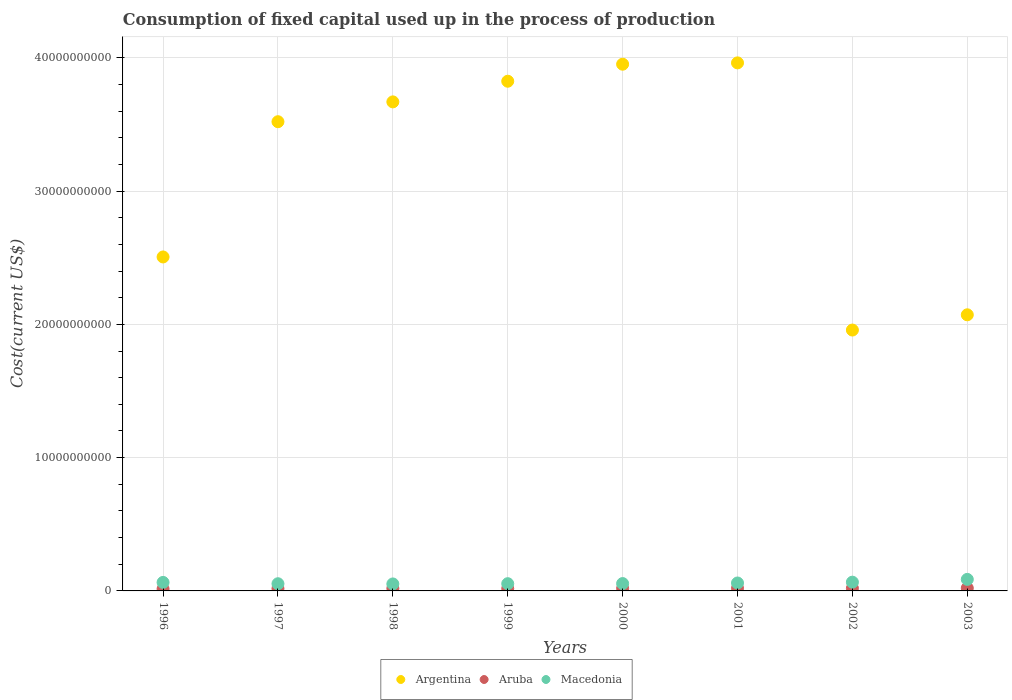How many different coloured dotlines are there?
Your answer should be compact. 3. What is the amount consumed in the process of production in Argentina in 2003?
Your response must be concise. 2.07e+1. Across all years, what is the maximum amount consumed in the process of production in Macedonia?
Offer a very short reply. 8.65e+08. Across all years, what is the minimum amount consumed in the process of production in Argentina?
Your answer should be very brief. 1.96e+1. In which year was the amount consumed in the process of production in Argentina minimum?
Provide a succinct answer. 2002. What is the total amount consumed in the process of production in Argentina in the graph?
Offer a very short reply. 2.55e+11. What is the difference between the amount consumed in the process of production in Macedonia in 1997 and that in 2000?
Your response must be concise. -1.24e+07. What is the difference between the amount consumed in the process of production in Aruba in 2003 and the amount consumed in the process of production in Argentina in 2001?
Your answer should be compact. -3.94e+1. What is the average amount consumed in the process of production in Macedonia per year?
Offer a terse response. 6.14e+08. In the year 2000, what is the difference between the amount consumed in the process of production in Argentina and amount consumed in the process of production in Aruba?
Keep it short and to the point. 3.93e+1. What is the ratio of the amount consumed in the process of production in Aruba in 1996 to that in 2000?
Your answer should be compact. 0.79. Is the difference between the amount consumed in the process of production in Argentina in 1998 and 2002 greater than the difference between the amount consumed in the process of production in Aruba in 1998 and 2002?
Keep it short and to the point. Yes. What is the difference between the highest and the second highest amount consumed in the process of production in Aruba?
Your response must be concise. 8.33e+06. What is the difference between the highest and the lowest amount consumed in the process of production in Macedonia?
Offer a very short reply. 3.42e+08. Does the amount consumed in the process of production in Aruba monotonically increase over the years?
Keep it short and to the point. No. Is the amount consumed in the process of production in Argentina strictly less than the amount consumed in the process of production in Aruba over the years?
Your answer should be very brief. No. How many years are there in the graph?
Offer a terse response. 8. Are the values on the major ticks of Y-axis written in scientific E-notation?
Provide a succinct answer. No. Does the graph contain any zero values?
Your response must be concise. No. Does the graph contain grids?
Ensure brevity in your answer.  Yes. Where does the legend appear in the graph?
Provide a short and direct response. Bottom center. How many legend labels are there?
Make the answer very short. 3. What is the title of the graph?
Provide a succinct answer. Consumption of fixed capital used up in the process of production. Does "Tanzania" appear as one of the legend labels in the graph?
Provide a short and direct response. No. What is the label or title of the X-axis?
Offer a terse response. Years. What is the label or title of the Y-axis?
Make the answer very short. Cost(current US$). What is the Cost(current US$) in Argentina in 1996?
Your response must be concise. 2.51e+1. What is the Cost(current US$) of Aruba in 1996?
Your answer should be very brief. 1.51e+08. What is the Cost(current US$) in Macedonia in 1996?
Ensure brevity in your answer.  6.38e+08. What is the Cost(current US$) of Argentina in 1997?
Your answer should be very brief. 3.52e+1. What is the Cost(current US$) of Aruba in 1997?
Your answer should be very brief. 1.73e+08. What is the Cost(current US$) in Macedonia in 1997?
Give a very brief answer. 5.39e+08. What is the Cost(current US$) in Argentina in 1998?
Offer a very short reply. 3.67e+1. What is the Cost(current US$) of Aruba in 1998?
Provide a short and direct response. 1.85e+08. What is the Cost(current US$) of Macedonia in 1998?
Give a very brief answer. 5.23e+08. What is the Cost(current US$) in Argentina in 1999?
Your answer should be very brief. 3.82e+1. What is the Cost(current US$) in Aruba in 1999?
Your response must be concise. 1.75e+08. What is the Cost(current US$) of Macedonia in 1999?
Your response must be concise. 5.43e+08. What is the Cost(current US$) in Argentina in 2000?
Keep it short and to the point. 3.95e+1. What is the Cost(current US$) of Aruba in 2000?
Offer a very short reply. 1.91e+08. What is the Cost(current US$) in Macedonia in 2000?
Provide a short and direct response. 5.52e+08. What is the Cost(current US$) in Argentina in 2001?
Your response must be concise. 3.96e+1. What is the Cost(current US$) of Aruba in 2001?
Give a very brief answer. 1.98e+08. What is the Cost(current US$) in Macedonia in 2001?
Offer a very short reply. 5.95e+08. What is the Cost(current US$) of Argentina in 2002?
Ensure brevity in your answer.  1.96e+1. What is the Cost(current US$) of Aruba in 2002?
Make the answer very short. 2.00e+08. What is the Cost(current US$) in Macedonia in 2002?
Offer a very short reply. 6.56e+08. What is the Cost(current US$) in Argentina in 2003?
Your answer should be very brief. 2.07e+1. What is the Cost(current US$) of Aruba in 2003?
Provide a succinct answer. 2.09e+08. What is the Cost(current US$) in Macedonia in 2003?
Your answer should be compact. 8.65e+08. Across all years, what is the maximum Cost(current US$) of Argentina?
Your answer should be very brief. 3.96e+1. Across all years, what is the maximum Cost(current US$) in Aruba?
Provide a short and direct response. 2.09e+08. Across all years, what is the maximum Cost(current US$) of Macedonia?
Make the answer very short. 8.65e+08. Across all years, what is the minimum Cost(current US$) of Argentina?
Your response must be concise. 1.96e+1. Across all years, what is the minimum Cost(current US$) in Aruba?
Provide a short and direct response. 1.51e+08. Across all years, what is the minimum Cost(current US$) in Macedonia?
Make the answer very short. 5.23e+08. What is the total Cost(current US$) of Argentina in the graph?
Your answer should be very brief. 2.55e+11. What is the total Cost(current US$) in Aruba in the graph?
Give a very brief answer. 1.48e+09. What is the total Cost(current US$) of Macedonia in the graph?
Your answer should be very brief. 4.91e+09. What is the difference between the Cost(current US$) of Argentina in 1996 and that in 1997?
Keep it short and to the point. -1.01e+1. What is the difference between the Cost(current US$) of Aruba in 1996 and that in 1997?
Make the answer very short. -2.18e+07. What is the difference between the Cost(current US$) of Macedonia in 1996 and that in 1997?
Your answer should be compact. 9.88e+07. What is the difference between the Cost(current US$) of Argentina in 1996 and that in 1998?
Provide a succinct answer. -1.16e+1. What is the difference between the Cost(current US$) in Aruba in 1996 and that in 1998?
Make the answer very short. -3.41e+07. What is the difference between the Cost(current US$) in Macedonia in 1996 and that in 1998?
Give a very brief answer. 1.15e+08. What is the difference between the Cost(current US$) in Argentina in 1996 and that in 1999?
Provide a short and direct response. -1.32e+1. What is the difference between the Cost(current US$) in Aruba in 1996 and that in 1999?
Your response must be concise. -2.41e+07. What is the difference between the Cost(current US$) of Macedonia in 1996 and that in 1999?
Offer a very short reply. 9.54e+07. What is the difference between the Cost(current US$) in Argentina in 1996 and that in 2000?
Your answer should be very brief. -1.45e+1. What is the difference between the Cost(current US$) of Aruba in 1996 and that in 2000?
Keep it short and to the point. -4.07e+07. What is the difference between the Cost(current US$) of Macedonia in 1996 and that in 2000?
Keep it short and to the point. 8.64e+07. What is the difference between the Cost(current US$) of Argentina in 1996 and that in 2001?
Offer a terse response. -1.46e+1. What is the difference between the Cost(current US$) in Aruba in 1996 and that in 2001?
Offer a terse response. -4.70e+07. What is the difference between the Cost(current US$) in Macedonia in 1996 and that in 2001?
Keep it short and to the point. 4.34e+07. What is the difference between the Cost(current US$) in Argentina in 1996 and that in 2002?
Your response must be concise. 5.48e+09. What is the difference between the Cost(current US$) in Aruba in 1996 and that in 2002?
Offer a very short reply. -4.95e+07. What is the difference between the Cost(current US$) in Macedonia in 1996 and that in 2002?
Your response must be concise. -1.80e+07. What is the difference between the Cost(current US$) of Argentina in 1996 and that in 2003?
Your response must be concise. 4.34e+09. What is the difference between the Cost(current US$) of Aruba in 1996 and that in 2003?
Ensure brevity in your answer.  -5.78e+07. What is the difference between the Cost(current US$) in Macedonia in 1996 and that in 2003?
Provide a succinct answer. -2.27e+08. What is the difference between the Cost(current US$) of Argentina in 1997 and that in 1998?
Your answer should be very brief. -1.49e+09. What is the difference between the Cost(current US$) of Aruba in 1997 and that in 1998?
Your answer should be very brief. -1.23e+07. What is the difference between the Cost(current US$) in Macedonia in 1997 and that in 1998?
Give a very brief answer. 1.57e+07. What is the difference between the Cost(current US$) of Argentina in 1997 and that in 1999?
Make the answer very short. -3.04e+09. What is the difference between the Cost(current US$) of Aruba in 1997 and that in 1999?
Your answer should be compact. -2.22e+06. What is the difference between the Cost(current US$) of Macedonia in 1997 and that in 1999?
Your answer should be very brief. -3.48e+06. What is the difference between the Cost(current US$) in Argentina in 1997 and that in 2000?
Your answer should be compact. -4.31e+09. What is the difference between the Cost(current US$) of Aruba in 1997 and that in 2000?
Provide a short and direct response. -1.88e+07. What is the difference between the Cost(current US$) of Macedonia in 1997 and that in 2000?
Offer a very short reply. -1.24e+07. What is the difference between the Cost(current US$) in Argentina in 1997 and that in 2001?
Your answer should be compact. -4.41e+09. What is the difference between the Cost(current US$) in Aruba in 1997 and that in 2001?
Make the answer very short. -2.51e+07. What is the difference between the Cost(current US$) of Macedonia in 1997 and that in 2001?
Provide a short and direct response. -5.55e+07. What is the difference between the Cost(current US$) in Argentina in 1997 and that in 2002?
Make the answer very short. 1.56e+1. What is the difference between the Cost(current US$) in Aruba in 1997 and that in 2002?
Offer a very short reply. -2.77e+07. What is the difference between the Cost(current US$) in Macedonia in 1997 and that in 2002?
Your response must be concise. -1.17e+08. What is the difference between the Cost(current US$) in Argentina in 1997 and that in 2003?
Make the answer very short. 1.45e+1. What is the difference between the Cost(current US$) in Aruba in 1997 and that in 2003?
Keep it short and to the point. -3.60e+07. What is the difference between the Cost(current US$) in Macedonia in 1997 and that in 2003?
Offer a terse response. -3.26e+08. What is the difference between the Cost(current US$) of Argentina in 1998 and that in 1999?
Provide a succinct answer. -1.55e+09. What is the difference between the Cost(current US$) in Aruba in 1998 and that in 1999?
Keep it short and to the point. 1.01e+07. What is the difference between the Cost(current US$) of Macedonia in 1998 and that in 1999?
Your response must be concise. -1.92e+07. What is the difference between the Cost(current US$) in Argentina in 1998 and that in 2000?
Give a very brief answer. -2.83e+09. What is the difference between the Cost(current US$) in Aruba in 1998 and that in 2000?
Provide a short and direct response. -6.54e+06. What is the difference between the Cost(current US$) in Macedonia in 1998 and that in 2000?
Offer a very short reply. -2.82e+07. What is the difference between the Cost(current US$) in Argentina in 1998 and that in 2001?
Offer a terse response. -2.93e+09. What is the difference between the Cost(current US$) of Aruba in 1998 and that in 2001?
Make the answer very short. -1.28e+07. What is the difference between the Cost(current US$) in Macedonia in 1998 and that in 2001?
Offer a very short reply. -7.12e+07. What is the difference between the Cost(current US$) in Argentina in 1998 and that in 2002?
Provide a short and direct response. 1.71e+1. What is the difference between the Cost(current US$) of Aruba in 1998 and that in 2002?
Keep it short and to the point. -1.54e+07. What is the difference between the Cost(current US$) of Macedonia in 1998 and that in 2002?
Offer a very short reply. -1.33e+08. What is the difference between the Cost(current US$) in Argentina in 1998 and that in 2003?
Your answer should be very brief. 1.60e+1. What is the difference between the Cost(current US$) of Aruba in 1998 and that in 2003?
Give a very brief answer. -2.37e+07. What is the difference between the Cost(current US$) of Macedonia in 1998 and that in 2003?
Provide a short and direct response. -3.42e+08. What is the difference between the Cost(current US$) in Argentina in 1999 and that in 2000?
Provide a short and direct response. -1.28e+09. What is the difference between the Cost(current US$) of Aruba in 1999 and that in 2000?
Make the answer very short. -1.66e+07. What is the difference between the Cost(current US$) in Macedonia in 1999 and that in 2000?
Ensure brevity in your answer.  -8.94e+06. What is the difference between the Cost(current US$) of Argentina in 1999 and that in 2001?
Keep it short and to the point. -1.38e+09. What is the difference between the Cost(current US$) of Aruba in 1999 and that in 2001?
Your response must be concise. -2.29e+07. What is the difference between the Cost(current US$) in Macedonia in 1999 and that in 2001?
Your answer should be compact. -5.20e+07. What is the difference between the Cost(current US$) of Argentina in 1999 and that in 2002?
Ensure brevity in your answer.  1.87e+1. What is the difference between the Cost(current US$) of Aruba in 1999 and that in 2002?
Give a very brief answer. -2.54e+07. What is the difference between the Cost(current US$) of Macedonia in 1999 and that in 2002?
Give a very brief answer. -1.13e+08. What is the difference between the Cost(current US$) in Argentina in 1999 and that in 2003?
Your answer should be compact. 1.75e+1. What is the difference between the Cost(current US$) of Aruba in 1999 and that in 2003?
Offer a terse response. -3.38e+07. What is the difference between the Cost(current US$) of Macedonia in 1999 and that in 2003?
Provide a succinct answer. -3.23e+08. What is the difference between the Cost(current US$) of Argentina in 2000 and that in 2001?
Ensure brevity in your answer.  -9.96e+07. What is the difference between the Cost(current US$) in Aruba in 2000 and that in 2001?
Offer a terse response. -6.28e+06. What is the difference between the Cost(current US$) of Macedonia in 2000 and that in 2001?
Keep it short and to the point. -4.30e+07. What is the difference between the Cost(current US$) in Argentina in 2000 and that in 2002?
Make the answer very short. 1.99e+1. What is the difference between the Cost(current US$) of Aruba in 2000 and that in 2002?
Your answer should be very brief. -8.83e+06. What is the difference between the Cost(current US$) in Macedonia in 2000 and that in 2002?
Keep it short and to the point. -1.04e+08. What is the difference between the Cost(current US$) in Argentina in 2000 and that in 2003?
Offer a very short reply. 1.88e+1. What is the difference between the Cost(current US$) of Aruba in 2000 and that in 2003?
Make the answer very short. -1.72e+07. What is the difference between the Cost(current US$) of Macedonia in 2000 and that in 2003?
Keep it short and to the point. -3.14e+08. What is the difference between the Cost(current US$) of Argentina in 2001 and that in 2002?
Your answer should be compact. 2.00e+1. What is the difference between the Cost(current US$) in Aruba in 2001 and that in 2002?
Ensure brevity in your answer.  -2.55e+06. What is the difference between the Cost(current US$) in Macedonia in 2001 and that in 2002?
Your response must be concise. -6.14e+07. What is the difference between the Cost(current US$) in Argentina in 2001 and that in 2003?
Offer a very short reply. 1.89e+1. What is the difference between the Cost(current US$) in Aruba in 2001 and that in 2003?
Your answer should be very brief. -1.09e+07. What is the difference between the Cost(current US$) in Macedonia in 2001 and that in 2003?
Offer a very short reply. -2.71e+08. What is the difference between the Cost(current US$) of Argentina in 2002 and that in 2003?
Provide a short and direct response. -1.14e+09. What is the difference between the Cost(current US$) in Aruba in 2002 and that in 2003?
Keep it short and to the point. -8.33e+06. What is the difference between the Cost(current US$) in Macedonia in 2002 and that in 2003?
Offer a terse response. -2.09e+08. What is the difference between the Cost(current US$) of Argentina in 1996 and the Cost(current US$) of Aruba in 1997?
Provide a short and direct response. 2.49e+1. What is the difference between the Cost(current US$) in Argentina in 1996 and the Cost(current US$) in Macedonia in 1997?
Keep it short and to the point. 2.45e+1. What is the difference between the Cost(current US$) of Aruba in 1996 and the Cost(current US$) of Macedonia in 1997?
Provide a succinct answer. -3.88e+08. What is the difference between the Cost(current US$) of Argentina in 1996 and the Cost(current US$) of Aruba in 1998?
Provide a succinct answer. 2.49e+1. What is the difference between the Cost(current US$) in Argentina in 1996 and the Cost(current US$) in Macedonia in 1998?
Provide a succinct answer. 2.45e+1. What is the difference between the Cost(current US$) in Aruba in 1996 and the Cost(current US$) in Macedonia in 1998?
Offer a very short reply. -3.73e+08. What is the difference between the Cost(current US$) in Argentina in 1996 and the Cost(current US$) in Aruba in 1999?
Provide a short and direct response. 2.49e+1. What is the difference between the Cost(current US$) of Argentina in 1996 and the Cost(current US$) of Macedonia in 1999?
Make the answer very short. 2.45e+1. What is the difference between the Cost(current US$) of Aruba in 1996 and the Cost(current US$) of Macedonia in 1999?
Give a very brief answer. -3.92e+08. What is the difference between the Cost(current US$) in Argentina in 1996 and the Cost(current US$) in Aruba in 2000?
Keep it short and to the point. 2.49e+1. What is the difference between the Cost(current US$) in Argentina in 1996 and the Cost(current US$) in Macedonia in 2000?
Provide a succinct answer. 2.45e+1. What is the difference between the Cost(current US$) in Aruba in 1996 and the Cost(current US$) in Macedonia in 2000?
Your answer should be compact. -4.01e+08. What is the difference between the Cost(current US$) in Argentina in 1996 and the Cost(current US$) in Aruba in 2001?
Your answer should be very brief. 2.49e+1. What is the difference between the Cost(current US$) of Argentina in 1996 and the Cost(current US$) of Macedonia in 2001?
Keep it short and to the point. 2.45e+1. What is the difference between the Cost(current US$) in Aruba in 1996 and the Cost(current US$) in Macedonia in 2001?
Your answer should be very brief. -4.44e+08. What is the difference between the Cost(current US$) in Argentina in 1996 and the Cost(current US$) in Aruba in 2002?
Keep it short and to the point. 2.49e+1. What is the difference between the Cost(current US$) in Argentina in 1996 and the Cost(current US$) in Macedonia in 2002?
Offer a very short reply. 2.44e+1. What is the difference between the Cost(current US$) of Aruba in 1996 and the Cost(current US$) of Macedonia in 2002?
Ensure brevity in your answer.  -5.05e+08. What is the difference between the Cost(current US$) of Argentina in 1996 and the Cost(current US$) of Aruba in 2003?
Offer a very short reply. 2.49e+1. What is the difference between the Cost(current US$) in Argentina in 1996 and the Cost(current US$) in Macedonia in 2003?
Your response must be concise. 2.42e+1. What is the difference between the Cost(current US$) in Aruba in 1996 and the Cost(current US$) in Macedonia in 2003?
Offer a very short reply. -7.15e+08. What is the difference between the Cost(current US$) in Argentina in 1997 and the Cost(current US$) in Aruba in 1998?
Give a very brief answer. 3.50e+1. What is the difference between the Cost(current US$) in Argentina in 1997 and the Cost(current US$) in Macedonia in 1998?
Ensure brevity in your answer.  3.47e+1. What is the difference between the Cost(current US$) in Aruba in 1997 and the Cost(current US$) in Macedonia in 1998?
Provide a short and direct response. -3.51e+08. What is the difference between the Cost(current US$) in Argentina in 1997 and the Cost(current US$) in Aruba in 1999?
Offer a terse response. 3.50e+1. What is the difference between the Cost(current US$) of Argentina in 1997 and the Cost(current US$) of Macedonia in 1999?
Your answer should be compact. 3.47e+1. What is the difference between the Cost(current US$) in Aruba in 1997 and the Cost(current US$) in Macedonia in 1999?
Keep it short and to the point. -3.70e+08. What is the difference between the Cost(current US$) of Argentina in 1997 and the Cost(current US$) of Aruba in 2000?
Ensure brevity in your answer.  3.50e+1. What is the difference between the Cost(current US$) of Argentina in 1997 and the Cost(current US$) of Macedonia in 2000?
Offer a very short reply. 3.47e+1. What is the difference between the Cost(current US$) in Aruba in 1997 and the Cost(current US$) in Macedonia in 2000?
Offer a very short reply. -3.79e+08. What is the difference between the Cost(current US$) in Argentina in 1997 and the Cost(current US$) in Aruba in 2001?
Keep it short and to the point. 3.50e+1. What is the difference between the Cost(current US$) of Argentina in 1997 and the Cost(current US$) of Macedonia in 2001?
Make the answer very short. 3.46e+1. What is the difference between the Cost(current US$) of Aruba in 1997 and the Cost(current US$) of Macedonia in 2001?
Keep it short and to the point. -4.22e+08. What is the difference between the Cost(current US$) in Argentina in 1997 and the Cost(current US$) in Aruba in 2002?
Give a very brief answer. 3.50e+1. What is the difference between the Cost(current US$) in Argentina in 1997 and the Cost(current US$) in Macedonia in 2002?
Provide a succinct answer. 3.46e+1. What is the difference between the Cost(current US$) of Aruba in 1997 and the Cost(current US$) of Macedonia in 2002?
Make the answer very short. -4.83e+08. What is the difference between the Cost(current US$) of Argentina in 1997 and the Cost(current US$) of Aruba in 2003?
Provide a succinct answer. 3.50e+1. What is the difference between the Cost(current US$) of Argentina in 1997 and the Cost(current US$) of Macedonia in 2003?
Give a very brief answer. 3.43e+1. What is the difference between the Cost(current US$) of Aruba in 1997 and the Cost(current US$) of Macedonia in 2003?
Ensure brevity in your answer.  -6.93e+08. What is the difference between the Cost(current US$) in Argentina in 1998 and the Cost(current US$) in Aruba in 1999?
Offer a very short reply. 3.65e+1. What is the difference between the Cost(current US$) in Argentina in 1998 and the Cost(current US$) in Macedonia in 1999?
Offer a very short reply. 3.62e+1. What is the difference between the Cost(current US$) in Aruba in 1998 and the Cost(current US$) in Macedonia in 1999?
Offer a terse response. -3.58e+08. What is the difference between the Cost(current US$) of Argentina in 1998 and the Cost(current US$) of Aruba in 2000?
Offer a terse response. 3.65e+1. What is the difference between the Cost(current US$) of Argentina in 1998 and the Cost(current US$) of Macedonia in 2000?
Keep it short and to the point. 3.61e+1. What is the difference between the Cost(current US$) of Aruba in 1998 and the Cost(current US$) of Macedonia in 2000?
Your response must be concise. -3.67e+08. What is the difference between the Cost(current US$) in Argentina in 1998 and the Cost(current US$) in Aruba in 2001?
Your answer should be compact. 3.65e+1. What is the difference between the Cost(current US$) in Argentina in 1998 and the Cost(current US$) in Macedonia in 2001?
Your answer should be compact. 3.61e+1. What is the difference between the Cost(current US$) of Aruba in 1998 and the Cost(current US$) of Macedonia in 2001?
Your answer should be very brief. -4.10e+08. What is the difference between the Cost(current US$) in Argentina in 1998 and the Cost(current US$) in Aruba in 2002?
Provide a short and direct response. 3.65e+1. What is the difference between the Cost(current US$) in Argentina in 1998 and the Cost(current US$) in Macedonia in 2002?
Your response must be concise. 3.60e+1. What is the difference between the Cost(current US$) in Aruba in 1998 and the Cost(current US$) in Macedonia in 2002?
Keep it short and to the point. -4.71e+08. What is the difference between the Cost(current US$) of Argentina in 1998 and the Cost(current US$) of Aruba in 2003?
Provide a short and direct response. 3.65e+1. What is the difference between the Cost(current US$) in Argentina in 1998 and the Cost(current US$) in Macedonia in 2003?
Make the answer very short. 3.58e+1. What is the difference between the Cost(current US$) in Aruba in 1998 and the Cost(current US$) in Macedonia in 2003?
Offer a very short reply. -6.80e+08. What is the difference between the Cost(current US$) in Argentina in 1999 and the Cost(current US$) in Aruba in 2000?
Offer a very short reply. 3.81e+1. What is the difference between the Cost(current US$) in Argentina in 1999 and the Cost(current US$) in Macedonia in 2000?
Provide a succinct answer. 3.77e+1. What is the difference between the Cost(current US$) of Aruba in 1999 and the Cost(current US$) of Macedonia in 2000?
Ensure brevity in your answer.  -3.77e+08. What is the difference between the Cost(current US$) of Argentina in 1999 and the Cost(current US$) of Aruba in 2001?
Ensure brevity in your answer.  3.80e+1. What is the difference between the Cost(current US$) in Argentina in 1999 and the Cost(current US$) in Macedonia in 2001?
Give a very brief answer. 3.77e+1. What is the difference between the Cost(current US$) in Aruba in 1999 and the Cost(current US$) in Macedonia in 2001?
Your response must be concise. -4.20e+08. What is the difference between the Cost(current US$) of Argentina in 1999 and the Cost(current US$) of Aruba in 2002?
Offer a terse response. 3.80e+1. What is the difference between the Cost(current US$) in Argentina in 1999 and the Cost(current US$) in Macedonia in 2002?
Keep it short and to the point. 3.76e+1. What is the difference between the Cost(current US$) of Aruba in 1999 and the Cost(current US$) of Macedonia in 2002?
Provide a succinct answer. -4.81e+08. What is the difference between the Cost(current US$) of Argentina in 1999 and the Cost(current US$) of Aruba in 2003?
Offer a very short reply. 3.80e+1. What is the difference between the Cost(current US$) of Argentina in 1999 and the Cost(current US$) of Macedonia in 2003?
Provide a succinct answer. 3.74e+1. What is the difference between the Cost(current US$) in Aruba in 1999 and the Cost(current US$) in Macedonia in 2003?
Provide a succinct answer. -6.91e+08. What is the difference between the Cost(current US$) in Argentina in 2000 and the Cost(current US$) in Aruba in 2001?
Give a very brief answer. 3.93e+1. What is the difference between the Cost(current US$) in Argentina in 2000 and the Cost(current US$) in Macedonia in 2001?
Give a very brief answer. 3.89e+1. What is the difference between the Cost(current US$) of Aruba in 2000 and the Cost(current US$) of Macedonia in 2001?
Your answer should be very brief. -4.03e+08. What is the difference between the Cost(current US$) in Argentina in 2000 and the Cost(current US$) in Aruba in 2002?
Keep it short and to the point. 3.93e+1. What is the difference between the Cost(current US$) in Argentina in 2000 and the Cost(current US$) in Macedonia in 2002?
Ensure brevity in your answer.  3.89e+1. What is the difference between the Cost(current US$) of Aruba in 2000 and the Cost(current US$) of Macedonia in 2002?
Provide a succinct answer. -4.65e+08. What is the difference between the Cost(current US$) of Argentina in 2000 and the Cost(current US$) of Aruba in 2003?
Your answer should be compact. 3.93e+1. What is the difference between the Cost(current US$) of Argentina in 2000 and the Cost(current US$) of Macedonia in 2003?
Your response must be concise. 3.87e+1. What is the difference between the Cost(current US$) in Aruba in 2000 and the Cost(current US$) in Macedonia in 2003?
Offer a very short reply. -6.74e+08. What is the difference between the Cost(current US$) in Argentina in 2001 and the Cost(current US$) in Aruba in 2002?
Offer a very short reply. 3.94e+1. What is the difference between the Cost(current US$) in Argentina in 2001 and the Cost(current US$) in Macedonia in 2002?
Offer a very short reply. 3.90e+1. What is the difference between the Cost(current US$) of Aruba in 2001 and the Cost(current US$) of Macedonia in 2002?
Your response must be concise. -4.58e+08. What is the difference between the Cost(current US$) in Argentina in 2001 and the Cost(current US$) in Aruba in 2003?
Provide a succinct answer. 3.94e+1. What is the difference between the Cost(current US$) of Argentina in 2001 and the Cost(current US$) of Macedonia in 2003?
Offer a very short reply. 3.88e+1. What is the difference between the Cost(current US$) in Aruba in 2001 and the Cost(current US$) in Macedonia in 2003?
Ensure brevity in your answer.  -6.68e+08. What is the difference between the Cost(current US$) of Argentina in 2002 and the Cost(current US$) of Aruba in 2003?
Give a very brief answer. 1.94e+1. What is the difference between the Cost(current US$) in Argentina in 2002 and the Cost(current US$) in Macedonia in 2003?
Your answer should be compact. 1.87e+1. What is the difference between the Cost(current US$) of Aruba in 2002 and the Cost(current US$) of Macedonia in 2003?
Offer a very short reply. -6.65e+08. What is the average Cost(current US$) in Argentina per year?
Keep it short and to the point. 3.18e+1. What is the average Cost(current US$) in Aruba per year?
Give a very brief answer. 1.85e+08. What is the average Cost(current US$) of Macedonia per year?
Your answer should be very brief. 6.14e+08. In the year 1996, what is the difference between the Cost(current US$) of Argentina and Cost(current US$) of Aruba?
Offer a very short reply. 2.49e+1. In the year 1996, what is the difference between the Cost(current US$) of Argentina and Cost(current US$) of Macedonia?
Offer a terse response. 2.44e+1. In the year 1996, what is the difference between the Cost(current US$) in Aruba and Cost(current US$) in Macedonia?
Make the answer very short. -4.87e+08. In the year 1997, what is the difference between the Cost(current US$) of Argentina and Cost(current US$) of Aruba?
Give a very brief answer. 3.50e+1. In the year 1997, what is the difference between the Cost(current US$) of Argentina and Cost(current US$) of Macedonia?
Make the answer very short. 3.47e+1. In the year 1997, what is the difference between the Cost(current US$) of Aruba and Cost(current US$) of Macedonia?
Ensure brevity in your answer.  -3.67e+08. In the year 1998, what is the difference between the Cost(current US$) of Argentina and Cost(current US$) of Aruba?
Your answer should be compact. 3.65e+1. In the year 1998, what is the difference between the Cost(current US$) of Argentina and Cost(current US$) of Macedonia?
Provide a succinct answer. 3.62e+1. In the year 1998, what is the difference between the Cost(current US$) of Aruba and Cost(current US$) of Macedonia?
Keep it short and to the point. -3.39e+08. In the year 1999, what is the difference between the Cost(current US$) of Argentina and Cost(current US$) of Aruba?
Your response must be concise. 3.81e+1. In the year 1999, what is the difference between the Cost(current US$) of Argentina and Cost(current US$) of Macedonia?
Ensure brevity in your answer.  3.77e+1. In the year 1999, what is the difference between the Cost(current US$) in Aruba and Cost(current US$) in Macedonia?
Make the answer very short. -3.68e+08. In the year 2000, what is the difference between the Cost(current US$) in Argentina and Cost(current US$) in Aruba?
Your answer should be compact. 3.93e+1. In the year 2000, what is the difference between the Cost(current US$) of Argentina and Cost(current US$) of Macedonia?
Offer a terse response. 3.90e+1. In the year 2000, what is the difference between the Cost(current US$) in Aruba and Cost(current US$) in Macedonia?
Keep it short and to the point. -3.60e+08. In the year 2001, what is the difference between the Cost(current US$) of Argentina and Cost(current US$) of Aruba?
Make the answer very short. 3.94e+1. In the year 2001, what is the difference between the Cost(current US$) of Argentina and Cost(current US$) of Macedonia?
Keep it short and to the point. 3.90e+1. In the year 2001, what is the difference between the Cost(current US$) of Aruba and Cost(current US$) of Macedonia?
Offer a terse response. -3.97e+08. In the year 2002, what is the difference between the Cost(current US$) in Argentina and Cost(current US$) in Aruba?
Ensure brevity in your answer.  1.94e+1. In the year 2002, what is the difference between the Cost(current US$) in Argentina and Cost(current US$) in Macedonia?
Your answer should be very brief. 1.89e+1. In the year 2002, what is the difference between the Cost(current US$) of Aruba and Cost(current US$) of Macedonia?
Provide a succinct answer. -4.56e+08. In the year 2003, what is the difference between the Cost(current US$) in Argentina and Cost(current US$) in Aruba?
Offer a very short reply. 2.05e+1. In the year 2003, what is the difference between the Cost(current US$) of Argentina and Cost(current US$) of Macedonia?
Keep it short and to the point. 1.99e+1. In the year 2003, what is the difference between the Cost(current US$) of Aruba and Cost(current US$) of Macedonia?
Make the answer very short. -6.57e+08. What is the ratio of the Cost(current US$) in Argentina in 1996 to that in 1997?
Provide a succinct answer. 0.71. What is the ratio of the Cost(current US$) of Aruba in 1996 to that in 1997?
Make the answer very short. 0.87. What is the ratio of the Cost(current US$) in Macedonia in 1996 to that in 1997?
Ensure brevity in your answer.  1.18. What is the ratio of the Cost(current US$) of Argentina in 1996 to that in 1998?
Make the answer very short. 0.68. What is the ratio of the Cost(current US$) of Aruba in 1996 to that in 1998?
Your answer should be compact. 0.82. What is the ratio of the Cost(current US$) in Macedonia in 1996 to that in 1998?
Ensure brevity in your answer.  1.22. What is the ratio of the Cost(current US$) of Argentina in 1996 to that in 1999?
Keep it short and to the point. 0.66. What is the ratio of the Cost(current US$) of Aruba in 1996 to that in 1999?
Offer a very short reply. 0.86. What is the ratio of the Cost(current US$) in Macedonia in 1996 to that in 1999?
Ensure brevity in your answer.  1.18. What is the ratio of the Cost(current US$) of Argentina in 1996 to that in 2000?
Make the answer very short. 0.63. What is the ratio of the Cost(current US$) in Aruba in 1996 to that in 2000?
Keep it short and to the point. 0.79. What is the ratio of the Cost(current US$) in Macedonia in 1996 to that in 2000?
Give a very brief answer. 1.16. What is the ratio of the Cost(current US$) in Argentina in 1996 to that in 2001?
Make the answer very short. 0.63. What is the ratio of the Cost(current US$) of Aruba in 1996 to that in 2001?
Ensure brevity in your answer.  0.76. What is the ratio of the Cost(current US$) in Macedonia in 1996 to that in 2001?
Ensure brevity in your answer.  1.07. What is the ratio of the Cost(current US$) in Argentina in 1996 to that in 2002?
Give a very brief answer. 1.28. What is the ratio of the Cost(current US$) in Aruba in 1996 to that in 2002?
Provide a short and direct response. 0.75. What is the ratio of the Cost(current US$) in Macedonia in 1996 to that in 2002?
Keep it short and to the point. 0.97. What is the ratio of the Cost(current US$) in Argentina in 1996 to that in 2003?
Provide a succinct answer. 1.21. What is the ratio of the Cost(current US$) of Aruba in 1996 to that in 2003?
Ensure brevity in your answer.  0.72. What is the ratio of the Cost(current US$) in Macedonia in 1996 to that in 2003?
Give a very brief answer. 0.74. What is the ratio of the Cost(current US$) of Argentina in 1997 to that in 1998?
Offer a very short reply. 0.96. What is the ratio of the Cost(current US$) of Aruba in 1997 to that in 1998?
Offer a terse response. 0.93. What is the ratio of the Cost(current US$) in Macedonia in 1997 to that in 1998?
Provide a short and direct response. 1.03. What is the ratio of the Cost(current US$) in Argentina in 1997 to that in 1999?
Your response must be concise. 0.92. What is the ratio of the Cost(current US$) in Aruba in 1997 to that in 1999?
Your answer should be very brief. 0.99. What is the ratio of the Cost(current US$) of Macedonia in 1997 to that in 1999?
Offer a terse response. 0.99. What is the ratio of the Cost(current US$) of Argentina in 1997 to that in 2000?
Offer a terse response. 0.89. What is the ratio of the Cost(current US$) in Aruba in 1997 to that in 2000?
Make the answer very short. 0.9. What is the ratio of the Cost(current US$) of Macedonia in 1997 to that in 2000?
Your answer should be compact. 0.98. What is the ratio of the Cost(current US$) in Argentina in 1997 to that in 2001?
Provide a short and direct response. 0.89. What is the ratio of the Cost(current US$) in Aruba in 1997 to that in 2001?
Offer a very short reply. 0.87. What is the ratio of the Cost(current US$) in Macedonia in 1997 to that in 2001?
Make the answer very short. 0.91. What is the ratio of the Cost(current US$) in Argentina in 1997 to that in 2002?
Your response must be concise. 1.8. What is the ratio of the Cost(current US$) in Aruba in 1997 to that in 2002?
Keep it short and to the point. 0.86. What is the ratio of the Cost(current US$) in Macedonia in 1997 to that in 2002?
Give a very brief answer. 0.82. What is the ratio of the Cost(current US$) in Argentina in 1997 to that in 2003?
Offer a terse response. 1.7. What is the ratio of the Cost(current US$) in Aruba in 1997 to that in 2003?
Your answer should be compact. 0.83. What is the ratio of the Cost(current US$) of Macedonia in 1997 to that in 2003?
Offer a very short reply. 0.62. What is the ratio of the Cost(current US$) of Argentina in 1998 to that in 1999?
Ensure brevity in your answer.  0.96. What is the ratio of the Cost(current US$) in Aruba in 1998 to that in 1999?
Your answer should be very brief. 1.06. What is the ratio of the Cost(current US$) in Macedonia in 1998 to that in 1999?
Provide a succinct answer. 0.96. What is the ratio of the Cost(current US$) of Argentina in 1998 to that in 2000?
Give a very brief answer. 0.93. What is the ratio of the Cost(current US$) of Aruba in 1998 to that in 2000?
Keep it short and to the point. 0.97. What is the ratio of the Cost(current US$) in Macedonia in 1998 to that in 2000?
Keep it short and to the point. 0.95. What is the ratio of the Cost(current US$) in Argentina in 1998 to that in 2001?
Your answer should be compact. 0.93. What is the ratio of the Cost(current US$) of Aruba in 1998 to that in 2001?
Give a very brief answer. 0.94. What is the ratio of the Cost(current US$) of Macedonia in 1998 to that in 2001?
Your answer should be compact. 0.88. What is the ratio of the Cost(current US$) in Argentina in 1998 to that in 2002?
Keep it short and to the point. 1.87. What is the ratio of the Cost(current US$) in Aruba in 1998 to that in 2002?
Offer a terse response. 0.92. What is the ratio of the Cost(current US$) in Macedonia in 1998 to that in 2002?
Keep it short and to the point. 0.8. What is the ratio of the Cost(current US$) in Argentina in 1998 to that in 2003?
Your answer should be very brief. 1.77. What is the ratio of the Cost(current US$) of Aruba in 1998 to that in 2003?
Provide a short and direct response. 0.89. What is the ratio of the Cost(current US$) of Macedonia in 1998 to that in 2003?
Give a very brief answer. 0.6. What is the ratio of the Cost(current US$) in Argentina in 1999 to that in 2000?
Ensure brevity in your answer.  0.97. What is the ratio of the Cost(current US$) of Aruba in 1999 to that in 2000?
Your answer should be compact. 0.91. What is the ratio of the Cost(current US$) in Macedonia in 1999 to that in 2000?
Your answer should be compact. 0.98. What is the ratio of the Cost(current US$) in Argentina in 1999 to that in 2001?
Offer a very short reply. 0.97. What is the ratio of the Cost(current US$) in Aruba in 1999 to that in 2001?
Make the answer very short. 0.88. What is the ratio of the Cost(current US$) in Macedonia in 1999 to that in 2001?
Offer a terse response. 0.91. What is the ratio of the Cost(current US$) of Argentina in 1999 to that in 2002?
Offer a terse response. 1.95. What is the ratio of the Cost(current US$) of Aruba in 1999 to that in 2002?
Provide a short and direct response. 0.87. What is the ratio of the Cost(current US$) in Macedonia in 1999 to that in 2002?
Give a very brief answer. 0.83. What is the ratio of the Cost(current US$) in Argentina in 1999 to that in 2003?
Your answer should be compact. 1.85. What is the ratio of the Cost(current US$) in Aruba in 1999 to that in 2003?
Your answer should be very brief. 0.84. What is the ratio of the Cost(current US$) of Macedonia in 1999 to that in 2003?
Ensure brevity in your answer.  0.63. What is the ratio of the Cost(current US$) in Aruba in 2000 to that in 2001?
Provide a short and direct response. 0.97. What is the ratio of the Cost(current US$) of Macedonia in 2000 to that in 2001?
Your response must be concise. 0.93. What is the ratio of the Cost(current US$) of Argentina in 2000 to that in 2002?
Your response must be concise. 2.02. What is the ratio of the Cost(current US$) in Aruba in 2000 to that in 2002?
Your answer should be compact. 0.96. What is the ratio of the Cost(current US$) in Macedonia in 2000 to that in 2002?
Offer a terse response. 0.84. What is the ratio of the Cost(current US$) of Argentina in 2000 to that in 2003?
Your response must be concise. 1.91. What is the ratio of the Cost(current US$) in Aruba in 2000 to that in 2003?
Your answer should be compact. 0.92. What is the ratio of the Cost(current US$) of Macedonia in 2000 to that in 2003?
Provide a short and direct response. 0.64. What is the ratio of the Cost(current US$) in Argentina in 2001 to that in 2002?
Offer a very short reply. 2.02. What is the ratio of the Cost(current US$) of Aruba in 2001 to that in 2002?
Offer a terse response. 0.99. What is the ratio of the Cost(current US$) of Macedonia in 2001 to that in 2002?
Provide a succinct answer. 0.91. What is the ratio of the Cost(current US$) in Argentina in 2001 to that in 2003?
Provide a short and direct response. 1.91. What is the ratio of the Cost(current US$) of Aruba in 2001 to that in 2003?
Ensure brevity in your answer.  0.95. What is the ratio of the Cost(current US$) in Macedonia in 2001 to that in 2003?
Make the answer very short. 0.69. What is the ratio of the Cost(current US$) of Argentina in 2002 to that in 2003?
Give a very brief answer. 0.94. What is the ratio of the Cost(current US$) of Aruba in 2002 to that in 2003?
Provide a short and direct response. 0.96. What is the ratio of the Cost(current US$) of Macedonia in 2002 to that in 2003?
Give a very brief answer. 0.76. What is the difference between the highest and the second highest Cost(current US$) of Argentina?
Your response must be concise. 9.96e+07. What is the difference between the highest and the second highest Cost(current US$) of Aruba?
Provide a short and direct response. 8.33e+06. What is the difference between the highest and the second highest Cost(current US$) in Macedonia?
Your answer should be compact. 2.09e+08. What is the difference between the highest and the lowest Cost(current US$) of Argentina?
Offer a very short reply. 2.00e+1. What is the difference between the highest and the lowest Cost(current US$) of Aruba?
Offer a terse response. 5.78e+07. What is the difference between the highest and the lowest Cost(current US$) in Macedonia?
Make the answer very short. 3.42e+08. 